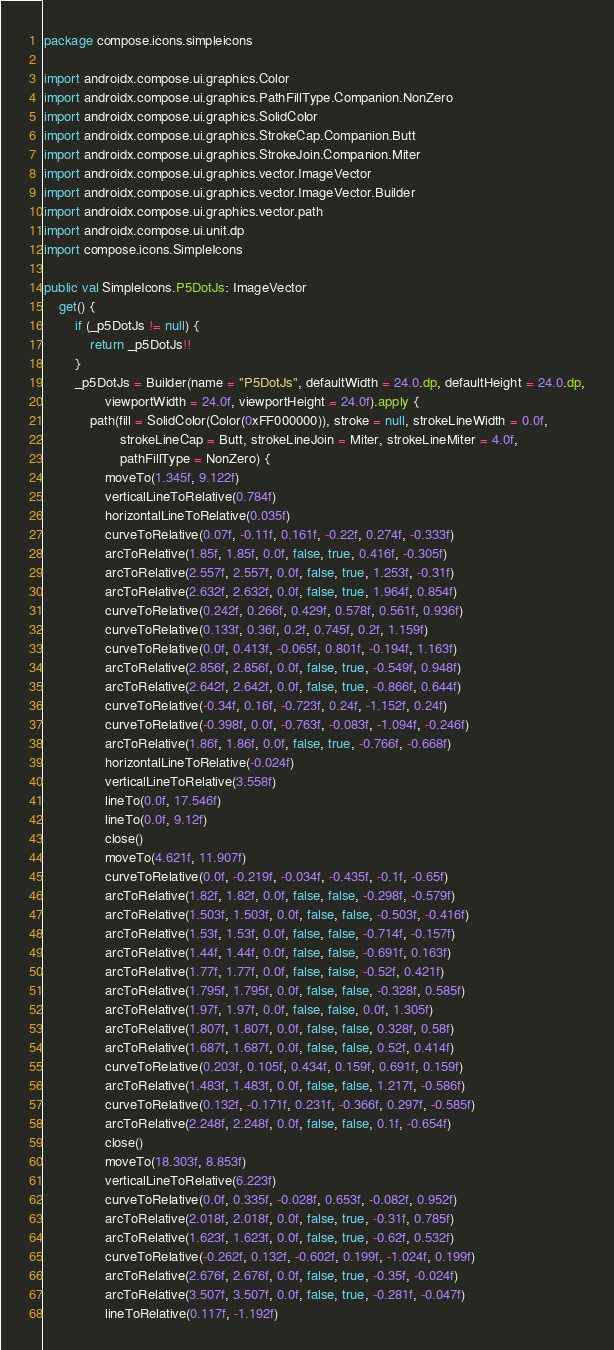<code> <loc_0><loc_0><loc_500><loc_500><_Kotlin_>package compose.icons.simpleicons

import androidx.compose.ui.graphics.Color
import androidx.compose.ui.graphics.PathFillType.Companion.NonZero
import androidx.compose.ui.graphics.SolidColor
import androidx.compose.ui.graphics.StrokeCap.Companion.Butt
import androidx.compose.ui.graphics.StrokeJoin.Companion.Miter
import androidx.compose.ui.graphics.vector.ImageVector
import androidx.compose.ui.graphics.vector.ImageVector.Builder
import androidx.compose.ui.graphics.vector.path
import androidx.compose.ui.unit.dp
import compose.icons.SimpleIcons

public val SimpleIcons.P5DotJs: ImageVector
    get() {
        if (_p5DotJs != null) {
            return _p5DotJs!!
        }
        _p5DotJs = Builder(name = "P5DotJs", defaultWidth = 24.0.dp, defaultHeight = 24.0.dp,
                viewportWidth = 24.0f, viewportHeight = 24.0f).apply {
            path(fill = SolidColor(Color(0xFF000000)), stroke = null, strokeLineWidth = 0.0f,
                    strokeLineCap = Butt, strokeLineJoin = Miter, strokeLineMiter = 4.0f,
                    pathFillType = NonZero) {
                moveTo(1.345f, 9.122f)
                verticalLineToRelative(0.784f)
                horizontalLineToRelative(0.035f)
                curveToRelative(0.07f, -0.11f, 0.161f, -0.22f, 0.274f, -0.333f)
                arcToRelative(1.85f, 1.85f, 0.0f, false, true, 0.416f, -0.305f)
                arcToRelative(2.557f, 2.557f, 0.0f, false, true, 1.253f, -0.31f)
                arcToRelative(2.632f, 2.632f, 0.0f, false, true, 1.964f, 0.854f)
                curveToRelative(0.242f, 0.266f, 0.429f, 0.578f, 0.561f, 0.936f)
                curveToRelative(0.133f, 0.36f, 0.2f, 0.745f, 0.2f, 1.159f)
                curveToRelative(0.0f, 0.413f, -0.065f, 0.801f, -0.194f, 1.163f)
                arcToRelative(2.856f, 2.856f, 0.0f, false, true, -0.549f, 0.948f)
                arcToRelative(2.642f, 2.642f, 0.0f, false, true, -0.866f, 0.644f)
                curveToRelative(-0.34f, 0.16f, -0.723f, 0.24f, -1.152f, 0.24f)
                curveToRelative(-0.398f, 0.0f, -0.763f, -0.083f, -1.094f, -0.246f)
                arcToRelative(1.86f, 1.86f, 0.0f, false, true, -0.766f, -0.668f)
                horizontalLineToRelative(-0.024f)
                verticalLineToRelative(3.558f)
                lineTo(0.0f, 17.546f)
                lineTo(0.0f, 9.12f)
                close()
                moveTo(4.621f, 11.907f)
                curveToRelative(0.0f, -0.219f, -0.034f, -0.435f, -0.1f, -0.65f)
                arcToRelative(1.82f, 1.82f, 0.0f, false, false, -0.298f, -0.579f)
                arcToRelative(1.503f, 1.503f, 0.0f, false, false, -0.503f, -0.416f)
                arcToRelative(1.53f, 1.53f, 0.0f, false, false, -0.714f, -0.157f)
                arcToRelative(1.44f, 1.44f, 0.0f, false, false, -0.691f, 0.163f)
                arcToRelative(1.77f, 1.77f, 0.0f, false, false, -0.52f, 0.421f)
                arcToRelative(1.795f, 1.795f, 0.0f, false, false, -0.328f, 0.585f)
                arcToRelative(1.97f, 1.97f, 0.0f, false, false, 0.0f, 1.305f)
                arcToRelative(1.807f, 1.807f, 0.0f, false, false, 0.328f, 0.58f)
                arcToRelative(1.687f, 1.687f, 0.0f, false, false, 0.52f, 0.414f)
                curveToRelative(0.203f, 0.105f, 0.434f, 0.159f, 0.691f, 0.159f)
                arcToRelative(1.483f, 1.483f, 0.0f, false, false, 1.217f, -0.586f)
                curveToRelative(0.132f, -0.171f, 0.231f, -0.366f, 0.297f, -0.585f)
                arcToRelative(2.248f, 2.248f, 0.0f, false, false, 0.1f, -0.654f)
                close()
                moveTo(18.303f, 8.853f)
                verticalLineToRelative(6.223f)
                curveToRelative(0.0f, 0.335f, -0.028f, 0.653f, -0.082f, 0.952f)
                arcToRelative(2.018f, 2.018f, 0.0f, false, true, -0.31f, 0.785f)
                arcToRelative(1.623f, 1.623f, 0.0f, false, true, -0.62f, 0.532f)
                curveToRelative(-0.262f, 0.132f, -0.602f, 0.199f, -1.024f, 0.199f)
                arcToRelative(2.676f, 2.676f, 0.0f, false, true, -0.35f, -0.024f)
                arcToRelative(3.507f, 3.507f, 0.0f, false, true, -0.281f, -0.047f)
                lineToRelative(0.117f, -1.192f)</code> 